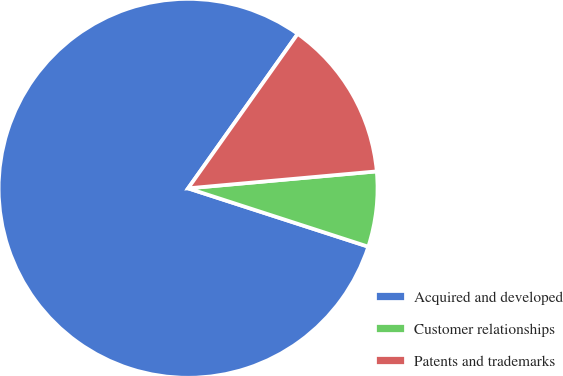<chart> <loc_0><loc_0><loc_500><loc_500><pie_chart><fcel>Acquired and developed<fcel>Customer relationships<fcel>Patents and trademarks<nl><fcel>79.83%<fcel>6.41%<fcel>13.75%<nl></chart> 